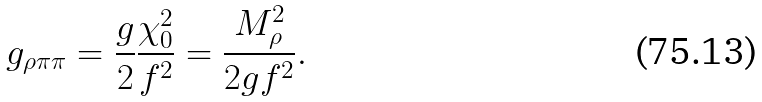Convert formula to latex. <formula><loc_0><loc_0><loc_500><loc_500>g _ { \rho \pi \pi } = \frac { g } { 2 } \frac { \chi ^ { 2 } _ { 0 } } { f ^ { 2 } } = \frac { M ^ { 2 } _ { \rho } } { 2 g f ^ { 2 } } .</formula> 